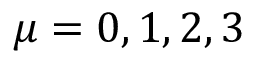Convert formula to latex. <formula><loc_0><loc_0><loc_500><loc_500>\mu = 0 , 1 , 2 , 3</formula> 